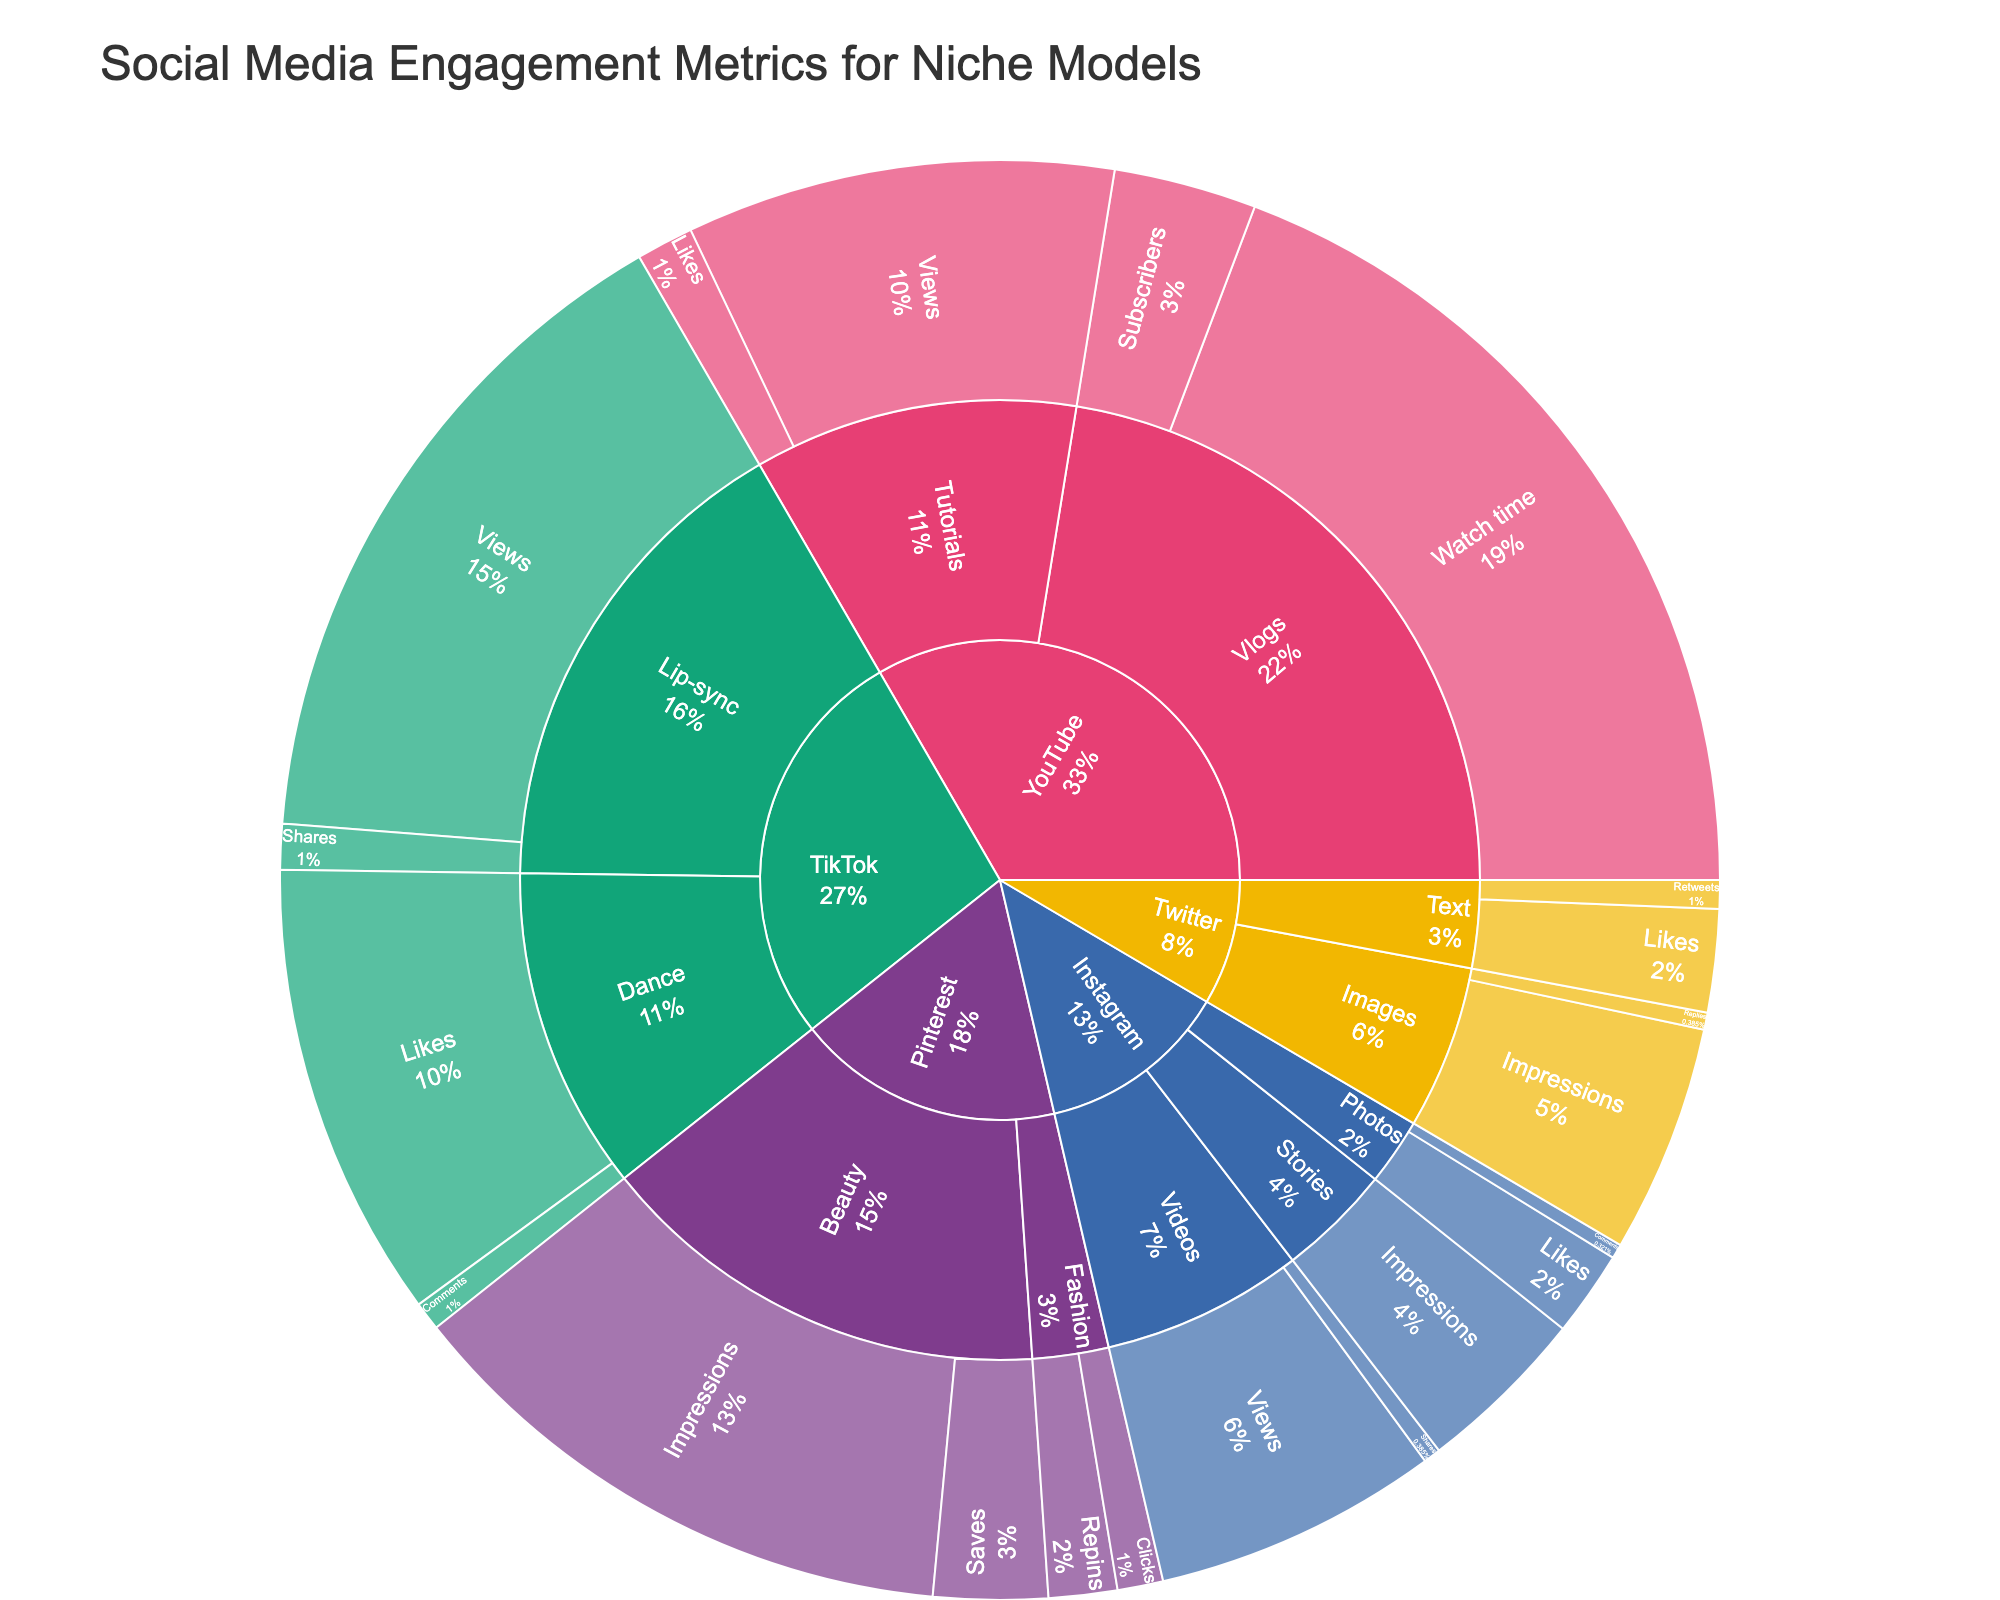What is the largest engagement metric for Instagram? To find the largest engagement metric for Instagram, look at the values associated with each content type (Photos, Videos, Stories). Instagram's largest metric is 50,000 for Video views.
Answer: 50,000 Which platform has the highest engagement metric overall? Examine the values for each platform. TikTok has the highest engagement metric with Lip-sync views reaching 120,000.
Answer: TikTok What's the total number of Likes across all platforms? Add up Likes from Instagram Photos (15,000), TikTok Dance (80,000), YouTube Tutorials (10,000), and Twitter Text (18,000). The total is 123,000.
Answer: 123,000 Which content type on YouTube received the highest Watch time? Look within the YouTube section and find the Watch time metric. Vlogs have the highest Watch time at 150,000.
Answer: Vlogs Compare the number of Impressions on Instagram Stories to Twitter Images. Which is higher and by how much? Instagram Stories have 30,000 Impressions and Twitter Images have 40,000. Twitter Images have 10,000 more Impressions.
Answer: Twitter Images, 10,000 more How do the Shares for TikTok Lip-sync compare to Instagram Videos? TikTok Lip-sync has 8,000 Shares while Instagram Videos have 3,000 Shares. TikTok Lip-sync has more Shares by 5,000.
Answer: TikTok Lip-sync, 5,000 more What is the difference in Comments between Instagram Photos and TikTok Dance? Instagram Photos have 2,500 Comments and TikTok Dance has 5,000 Comments. The difference is 2,500.
Answer: 2,500 What's the total number of Engagement types (e.g., Likes, Comments, etc.) for Pinterest? Pinterest includes Fashion (Repins, Clicks) and Beauty (Saves, Impressions) with a total of 4 different engagement types.
Answer: 4 Which platform has more diverse engagement types, Twitter or YouTube, and how many more types? Twitter has Retweets, Likes, Impressions, Replies (4 types), while YouTube has Subscribers, Watch time, Views, Likes (4 types). Both have the same number of engagement types.
Answer: Equal, 0 more What's the average value of Views across all platforms? Add up the Views for Instagram Videos (50,000), TikTok Lip-sync (120,000), and YouTube Tutorials (75,000) which totals 245,000, then divide by the number of data points (3). The average is 81,666.67.
Answer: 81,667 